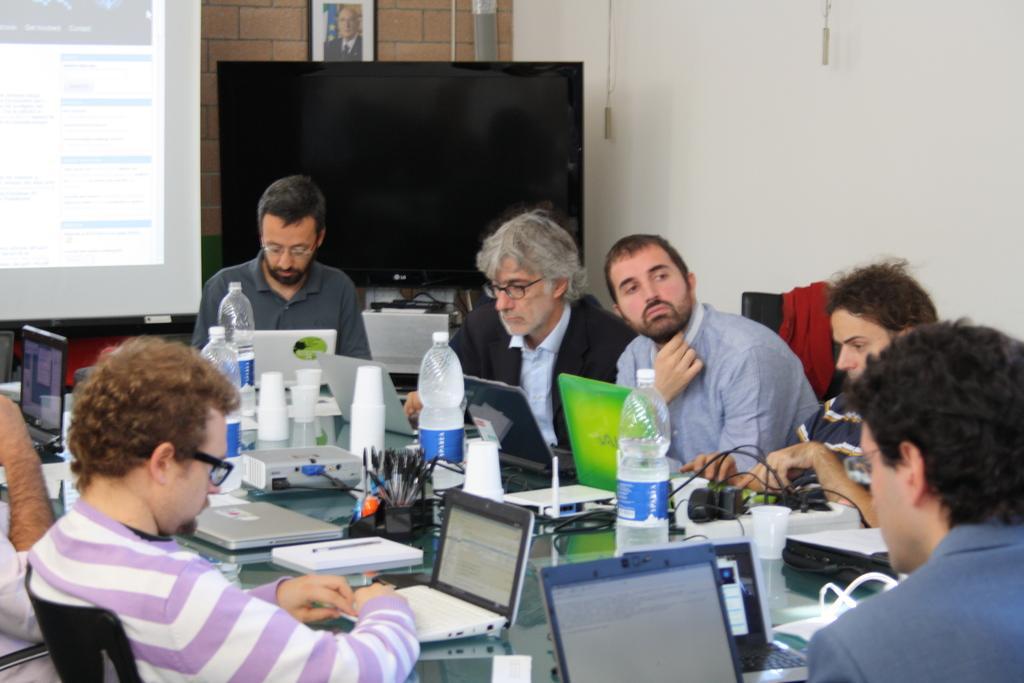How would you summarize this image in a sentence or two? There are group of people sitting around the table, working with the laptops. In front of them, there are bottles, pens and other items on the table. In the background, there is a wall, TV, and a screen. 